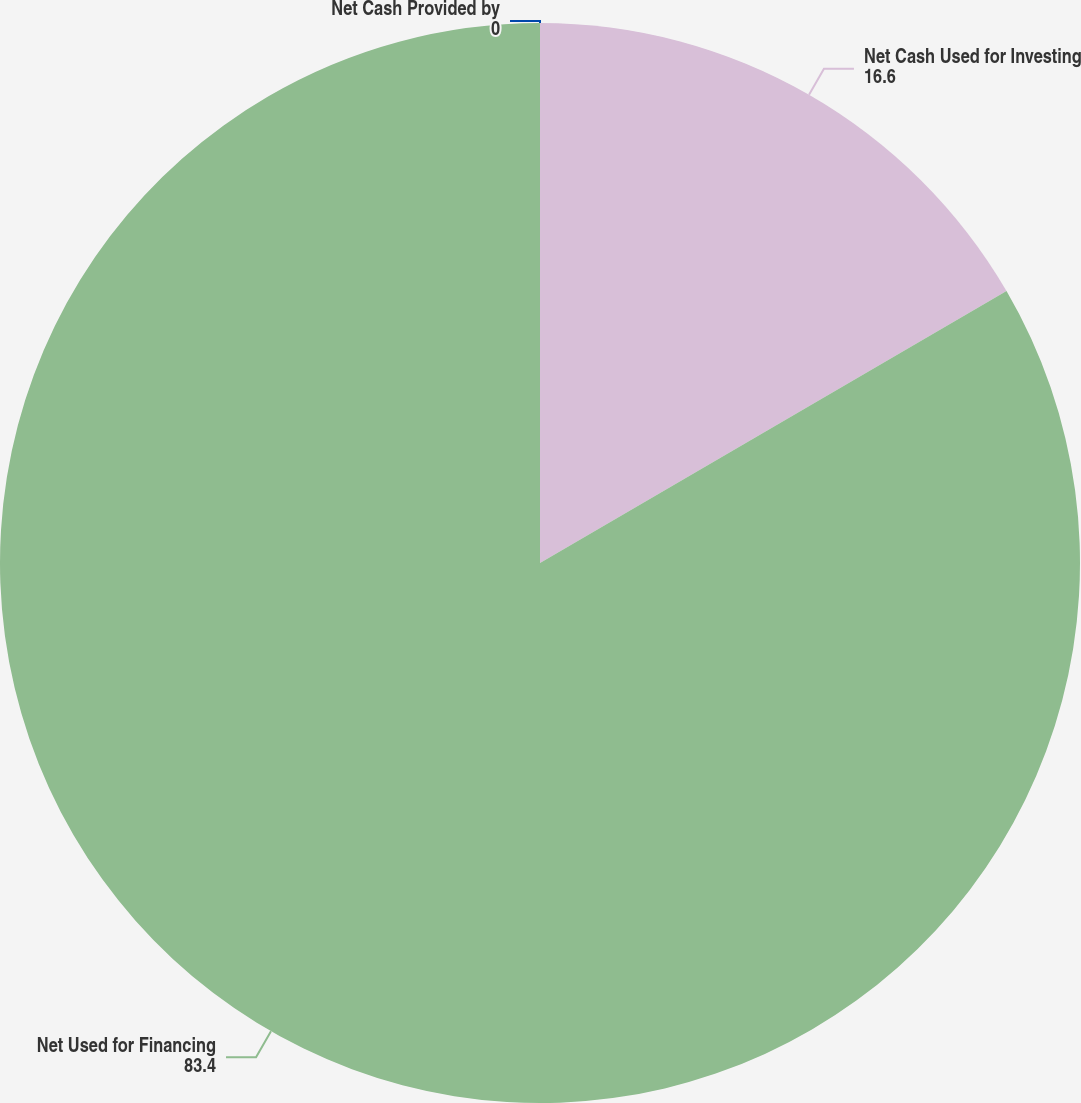<chart> <loc_0><loc_0><loc_500><loc_500><pie_chart><fcel>Net Cash Provided by<fcel>Net Cash Used for Investing<fcel>Net Used for Financing<nl><fcel>0.0%<fcel>16.6%<fcel>83.4%<nl></chart> 